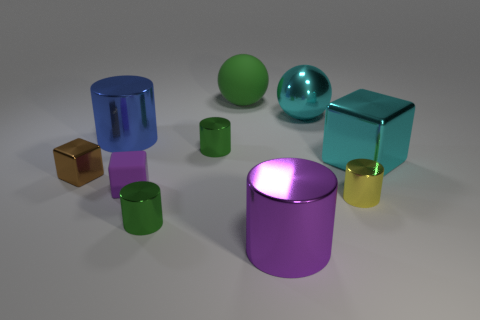What number of things are big spheres on the left side of the large purple cylinder or tiny green metal objects?
Offer a very short reply. 3. What number of small cylinders are there?
Provide a short and direct response. 3. The blue object that is made of the same material as the brown block is what shape?
Your answer should be very brief. Cylinder. There is a cyan thing in front of the large metallic cylinder that is behind the purple matte object; how big is it?
Provide a succinct answer. Large. How many objects are either purple metal cylinders in front of the yellow metallic object or big blue cylinders behind the small purple object?
Ensure brevity in your answer.  2. Are there fewer big green spheres than small green objects?
Your response must be concise. Yes. How many things are large cyan spheres or blue metal objects?
Ensure brevity in your answer.  2. Is the big purple shiny object the same shape as the blue object?
Your answer should be very brief. Yes. Does the green metal thing that is behind the small yellow cylinder have the same size as the matte thing behind the big cyan block?
Offer a very short reply. No. What is the material of the block that is both on the right side of the tiny brown cube and to the left of the big cube?
Your response must be concise. Rubber. 